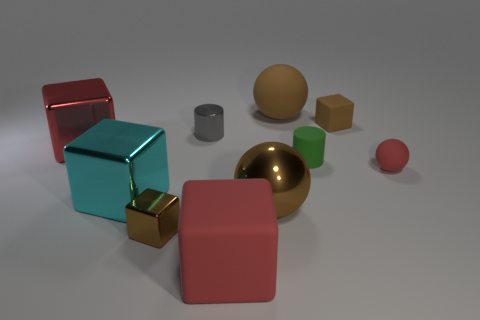The small block that is the same material as the cyan object is what color?
Offer a terse response. Brown. Does the small matte cylinder have the same color as the tiny block on the left side of the gray cylinder?
Ensure brevity in your answer.  No. How many things are either tiny cylinders that are on the right side of the big brown metallic sphere or objects that are on the right side of the tiny gray thing?
Provide a short and direct response. 6. What is the material of the cyan cube that is the same size as the red metal thing?
Ensure brevity in your answer.  Metal. What number of other things are there of the same material as the green cylinder
Provide a short and direct response. 4. Does the large brown object in front of the green matte thing have the same shape as the tiny green rubber thing behind the large metallic ball?
Your response must be concise. No. The small block on the left side of the brown cube that is on the right side of the large rubber object in front of the green object is what color?
Your answer should be very brief. Brown. How many other things are there of the same color as the shiny sphere?
Your answer should be very brief. 3. Are there fewer large rubber balls than large cyan rubber cubes?
Offer a very short reply. No. The object that is both to the left of the gray cylinder and in front of the big cyan cube is what color?
Keep it short and to the point. Brown. 